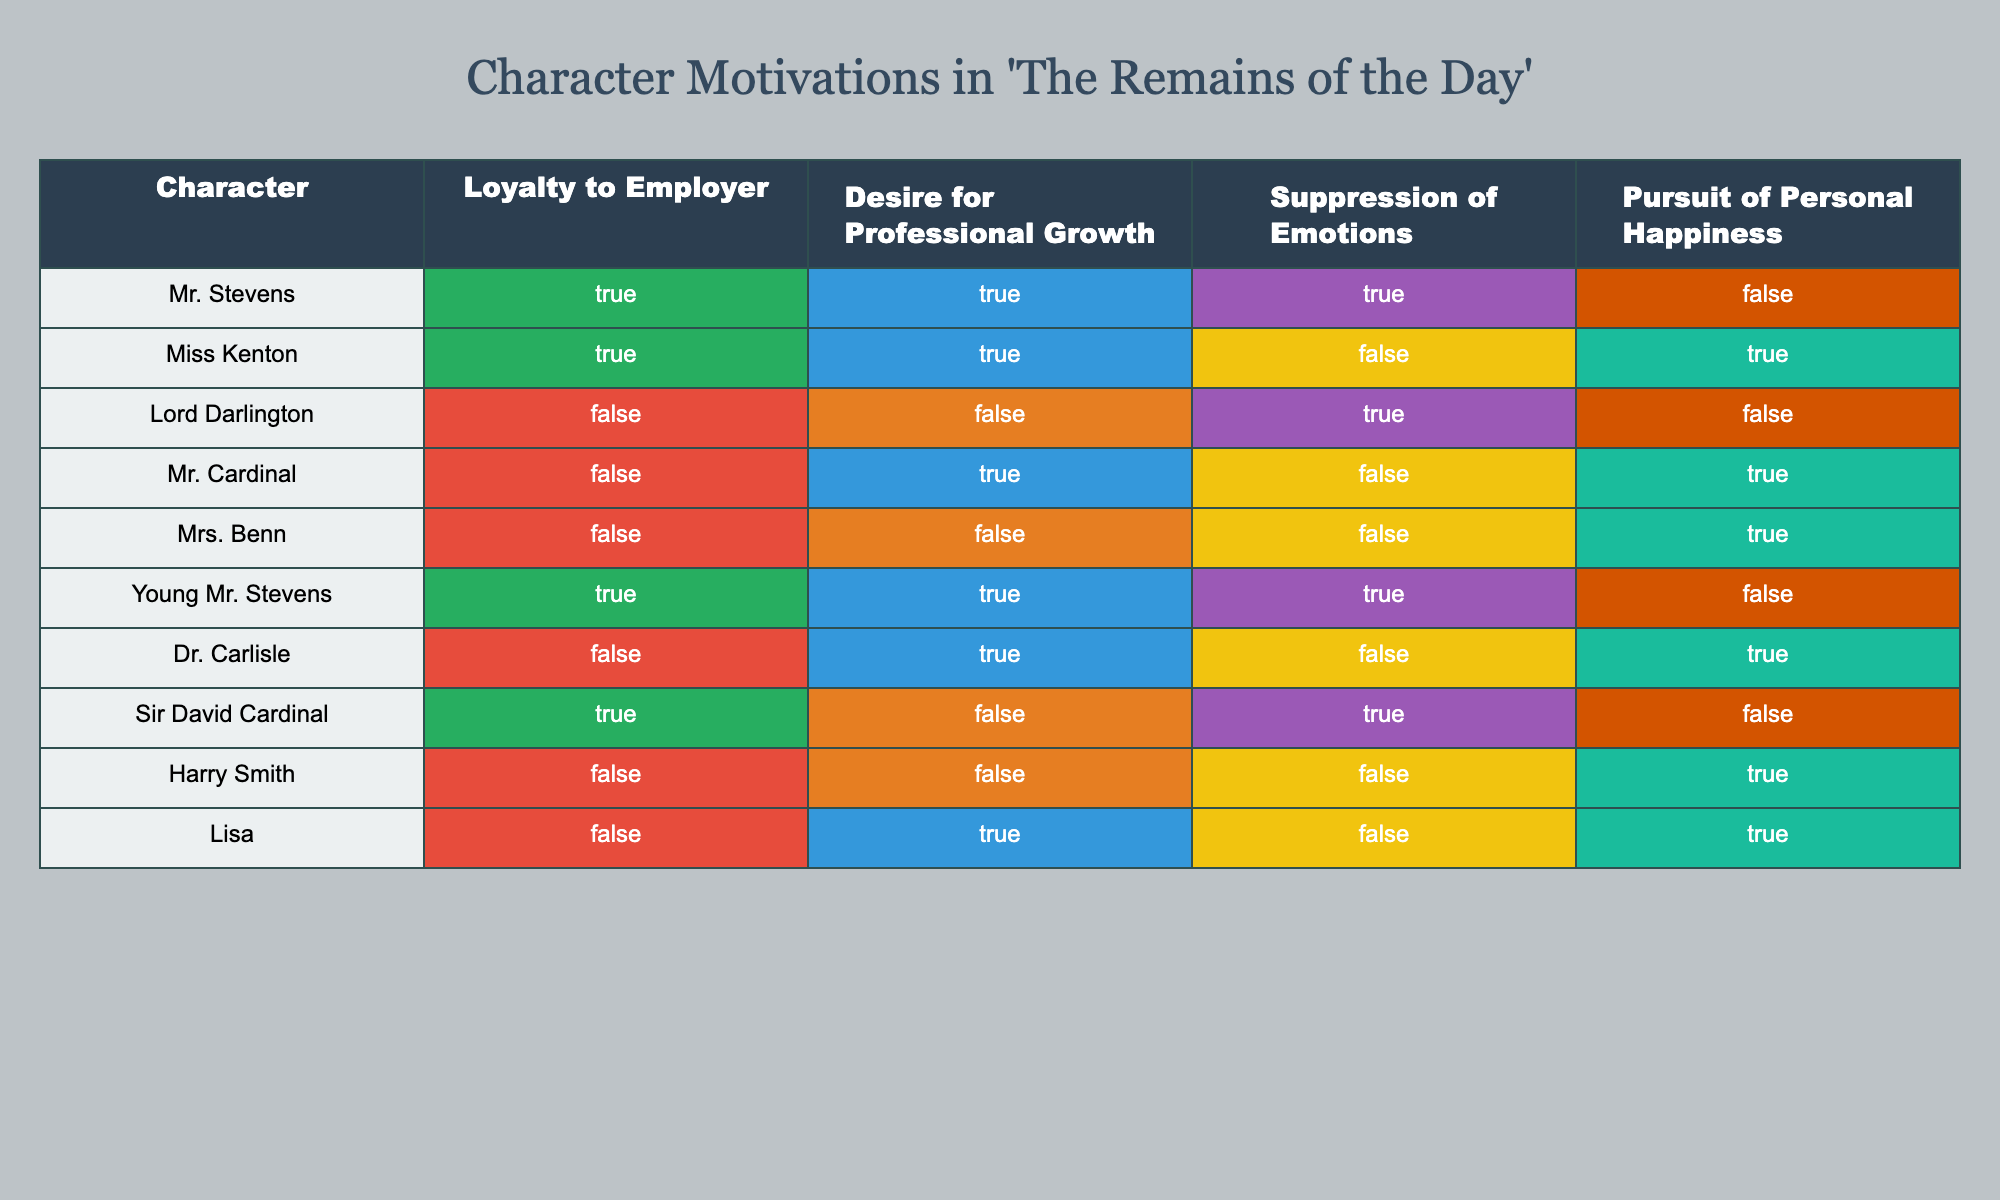What is the loyalty status of Mr. Stevens towards his employer? Looking at the table, the row for Mr. Stevens shows that the value under "Loyalty to Employer" is TRUE.
Answer: TRUE How many characters exhibit a desire for professional growth? We can count the characters who have TRUE in the "Desire for Professional Growth" column. Those are Mr. Stevens, Miss Kenton, Young Mr. Stevens, Mr. Cardinal, and Lisa, totaling 5 characters.
Answer: 5 Is Lord Darlington characterized by a desire for personal happiness? The table indicates that Lord Darlington has a FALSE value under "Pursuit of Personal Happiness."
Answer: FALSE Which character has the highest suppression of emotions? Reviewing the table, the values indicate that Mr. Stevens, Lord Darlington, Sir David Cardinal, and Young Mr. Stevens all have TRUE under "Suppression of Emotions." Among them, only Mr. Stevens is notable for having any complex motivations; however, since the query seeks the highest instance, Mr. Stevens, with 3 TRUE motivations, stands out.
Answer: Mr. Stevens How many characters prioritize personal happiness over loyalty to their employer? To find the answer, I will check each row where "Pursuit of Personal Happiness" is TRUE and "Loyalty to Employer" is FALSE. Those characters are Lord Darlington, Mrs. Benn, Harry Smith, and Lisa, summing up to 4 characters.
Answer: 4 List the characters that are both loyal to their employer and desire personal happiness. By filtering the table, Mr. Stevens and Young Mr. Stevens exhibit loyalty and have no values indicating a desire for personal happiness, hence none matches both criteria together.
Answer: None How many characters show a combination of high emotional suppression and a desire for professional growth? I will look within the characters who meet both TRUE conditions: Mr. Cardinal and Young Mr. Stevens show these combinations, adding up to 2 characters.
Answer: 2 Which character is loyal to their employer but does not pursue personal happiness? Identifying this character requires looking for a character with TRUE under "Loyalty to Employer" but FALSE under "Pursuit of Personal Happiness." Mr. Stevens (TRUE, FALSE) and Sir David Cardinal (TRUE, FALSE) fulfill this criteria.
Answer: Mr. Stevens and Sir David Cardinal Does the majority of characters prefer professional growth over personal happiness? By assessing the counts in the table, there are 5 TRUE values for "Desire for Professional Growth" and 4 TRUE values for "Pursuit of Personal Happiness." Therefore, professional growth is preferred by the majority showing values on this metric.
Answer: YES 